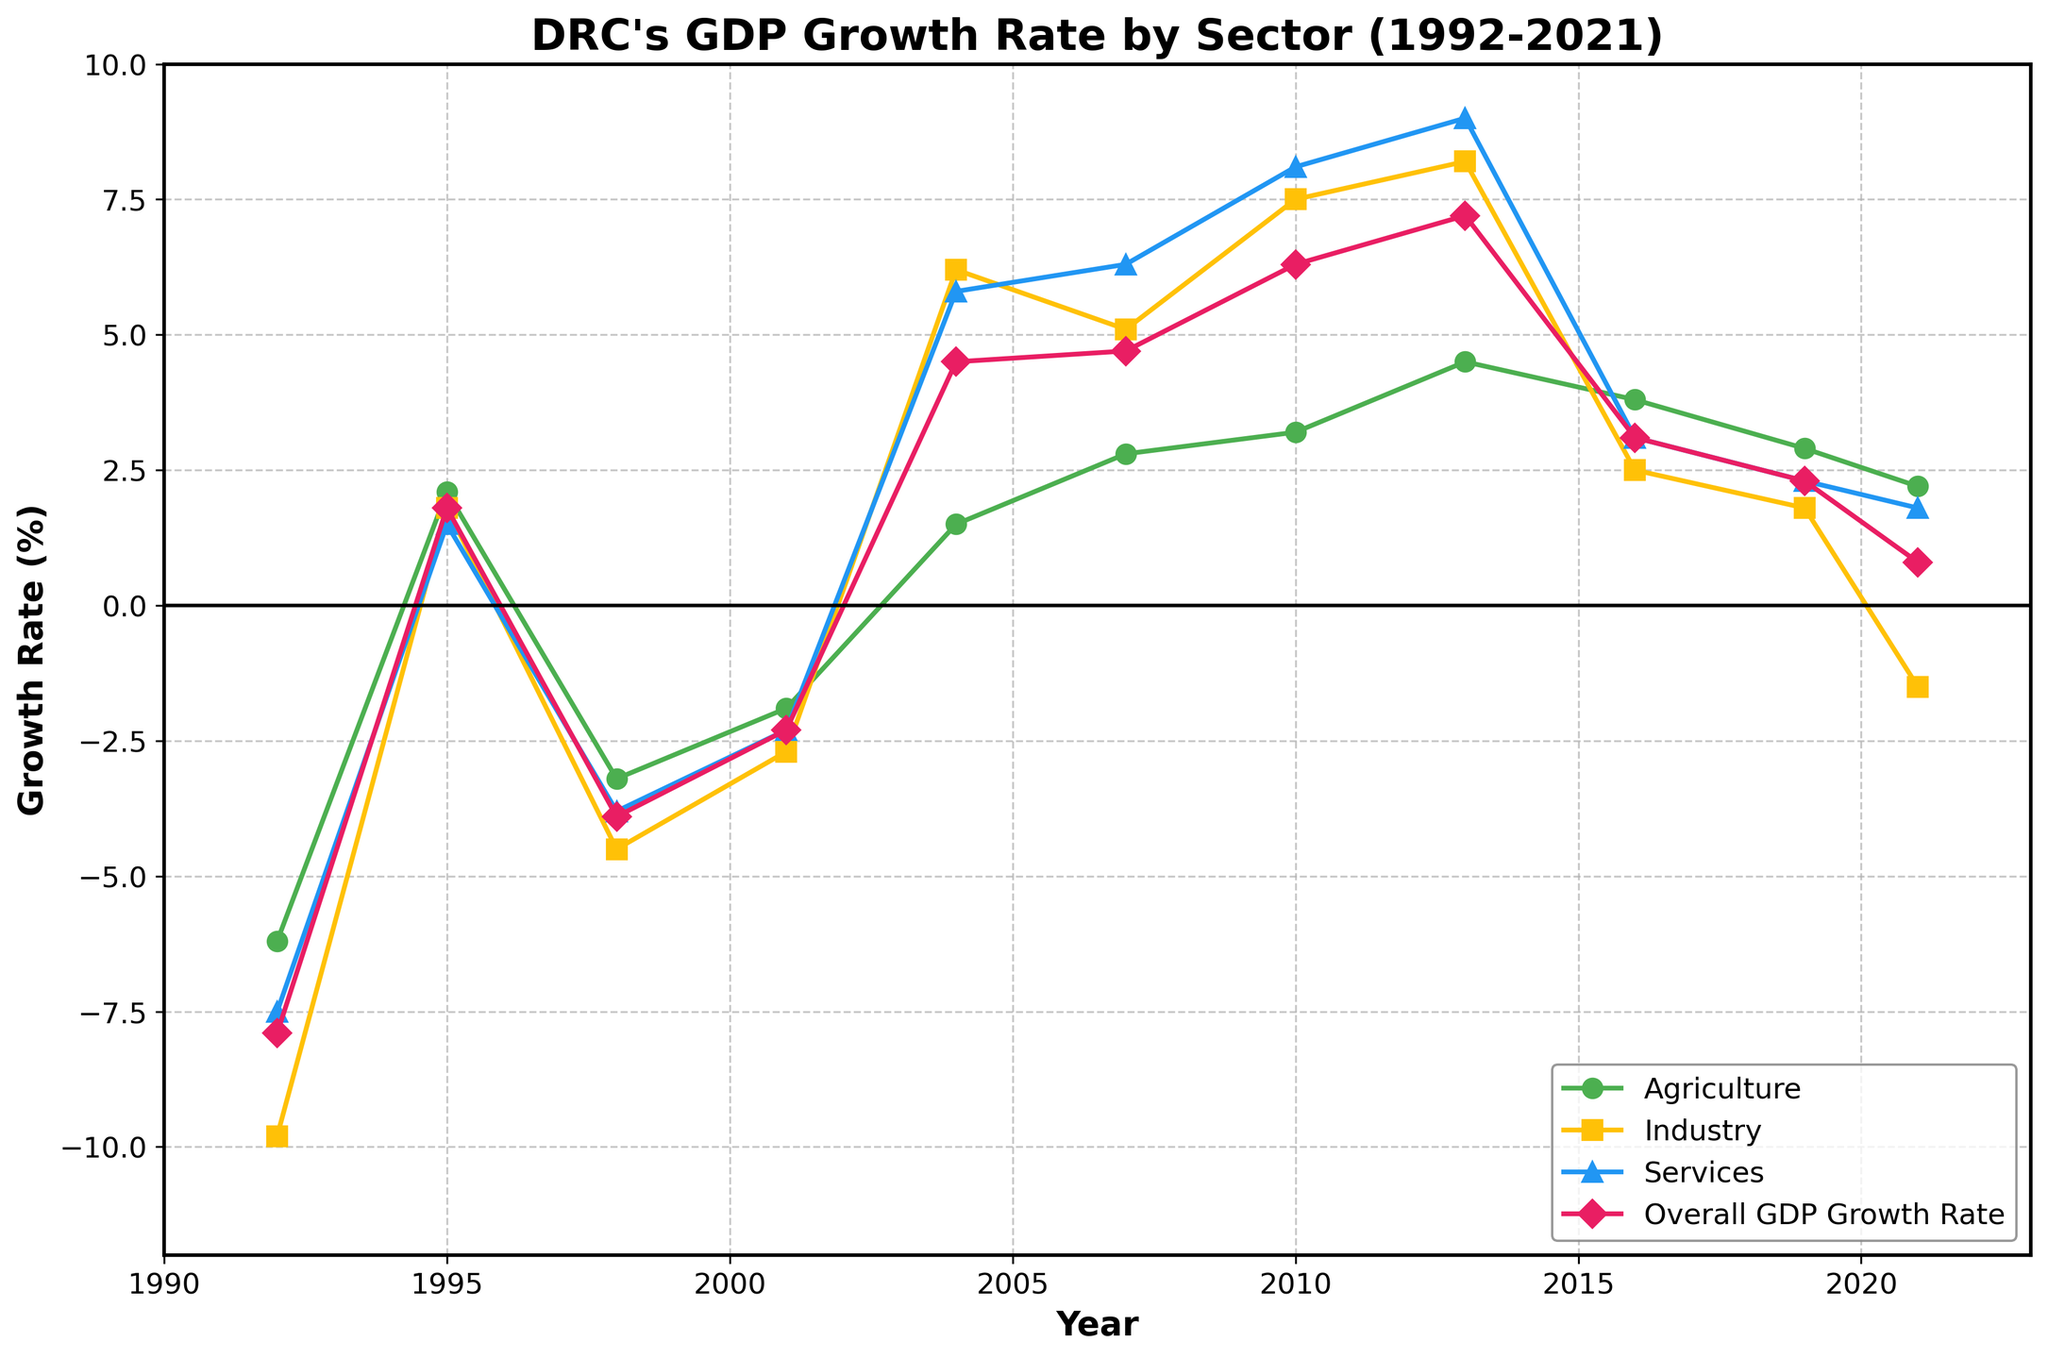what is the highest growth rate for the Services sector? The highest point on the Services sector line (blue) is in the year 2013 where the growth rate is plotted.
Answer: 9.0 Which sector had the lowest growth rate in 1992? By looking at the lines corresponding to 1992, the lowest point is for the Industry sector (orange) at -9.8%
Answer: Industry How did the Overall GDP growth rate change between 1998 and 2001? Check the relative positions of the Overall GDP Growth Rate line (pink) between 1998 and 2001. It moves from -3.9% in 1998 to -2.3% in 2001.
Answer: Increased by 1.6% In which year did Agriculture achieve its highest growth rate, and what was the rate? The highest point on the Agriculture line (green) occurs in 2013 where the rate is provided.
Answer: 4.5% in 2013 Did the Industry sector ever have negative growth after 2001? If so, which years? Examining the Industry sector line (orange) reveals a negative value only in 2021 at -1.5% after 2001.
Answer: Yes, in 2021 Compare the Services sector growth rate in 2007 to its growth rate in 2010. Check the points on the Services line (blue) for 2007 and 2010. The 2007 value is 6.3% and the 2010 value is 8.1%.
Answer: Increased by 1.8% How many sectors experienced a positive growth rate in 2004? Look at the data points for all sectors in 2004. Agriculture saw a 1.5%, Industry saw 6.2%, Services saw 5.8%, and Overall GDP Growth Rate was 4.5%.
Answer: Three sectors What is the average GDP growth rate for the years where the GDP was negative? Find all the years where the Overall GDP Growth Rate was negative (1992, 1998, 2001, 2021). Sum the rates (-7.9 - 3.9 - 2.3 + 0.8) = -14.2. There are 4 data points, and -14.2 / 4 = -3.55.
Answer: -3.55 Which year saw the highest overall GDP growth rate and what were the rates for each sector in that year? The highest point on the Overall GDP Growth Rate line (pink) occurs in 2013 at 7.2%. Reviewing the sector data for 2013: Agriculture 4.5%, Industry 8.2%, Services 9.0%.
Answer: 2013, Agriculture: 4.5%, Industry: 8.2%, Services: 9.0% 